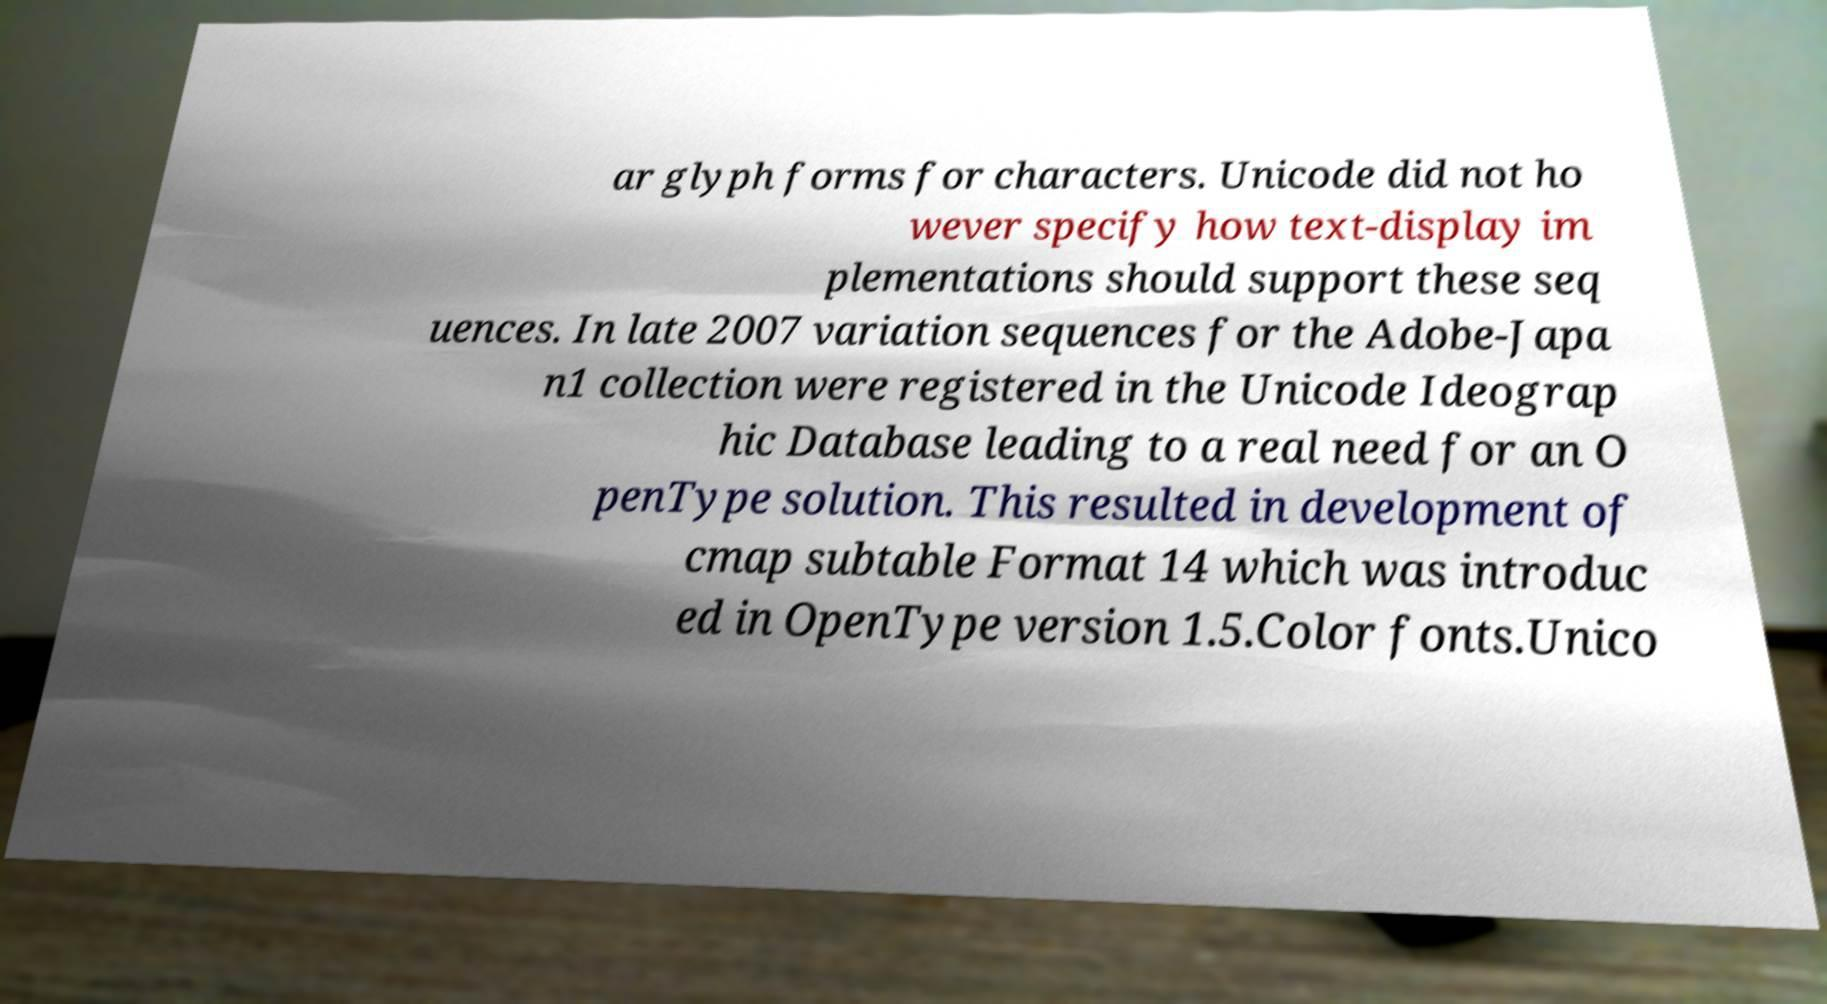I need the written content from this picture converted into text. Can you do that? ar glyph forms for characters. Unicode did not ho wever specify how text-display im plementations should support these seq uences. In late 2007 variation sequences for the Adobe-Japa n1 collection were registered in the Unicode Ideograp hic Database leading to a real need for an O penType solution. This resulted in development of cmap subtable Format 14 which was introduc ed in OpenType version 1.5.Color fonts.Unico 